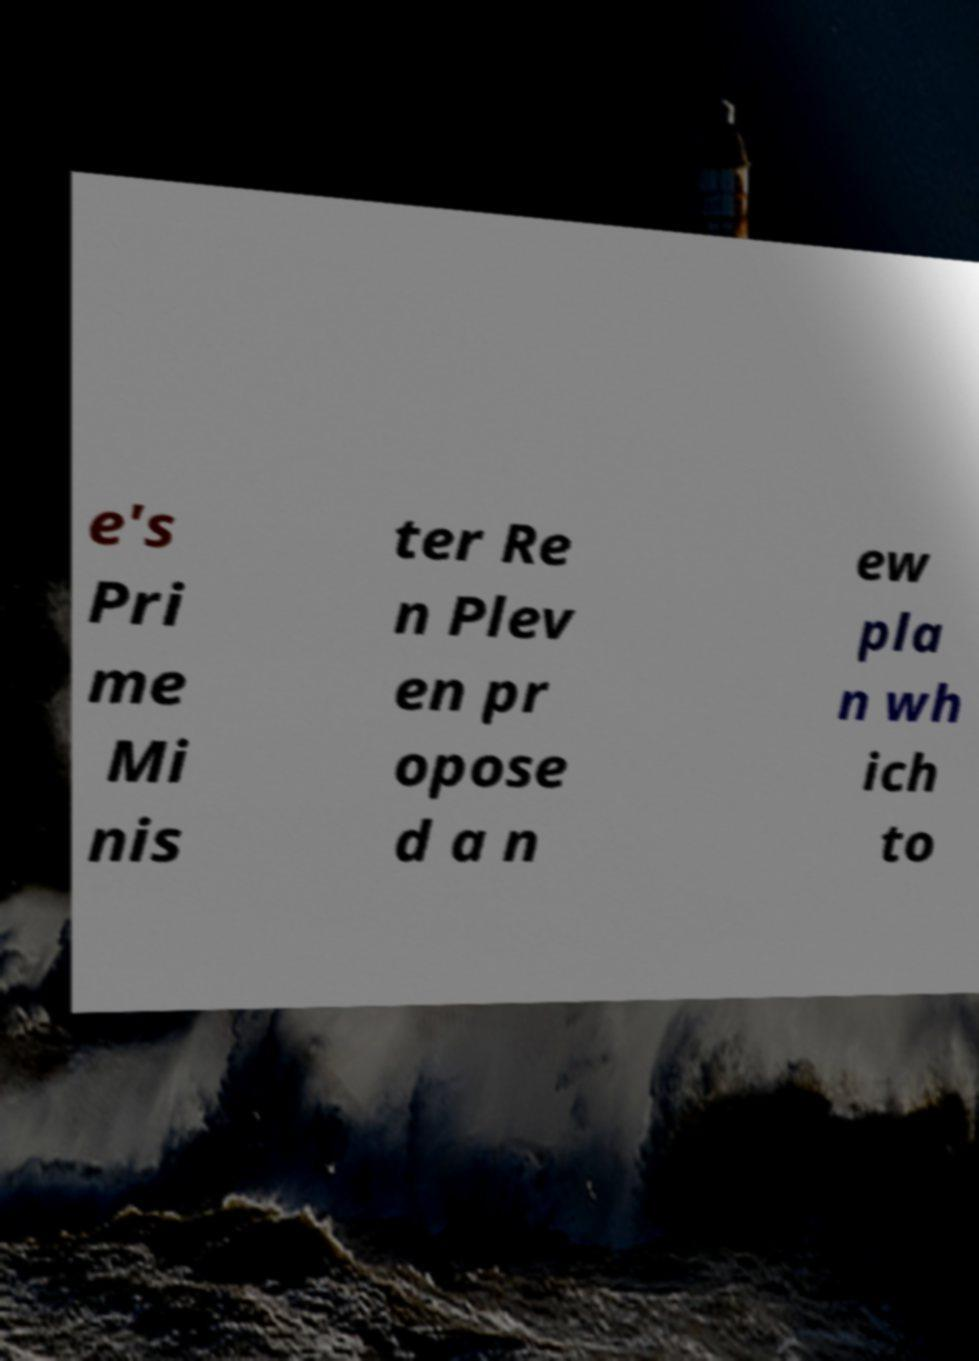Please read and relay the text visible in this image. What does it say? e's Pri me Mi nis ter Re n Plev en pr opose d a n ew pla n wh ich to 